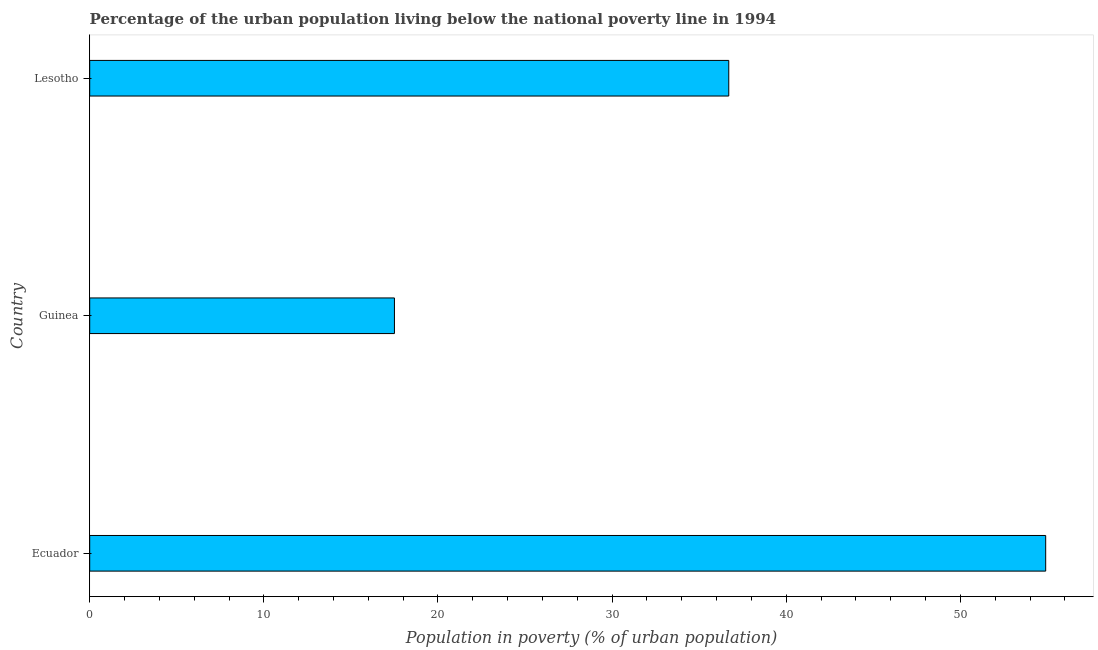Does the graph contain grids?
Your response must be concise. No. What is the title of the graph?
Give a very brief answer. Percentage of the urban population living below the national poverty line in 1994. What is the label or title of the X-axis?
Your answer should be compact. Population in poverty (% of urban population). What is the label or title of the Y-axis?
Give a very brief answer. Country. What is the percentage of urban population living below poverty line in Guinea?
Offer a terse response. 17.5. Across all countries, what is the maximum percentage of urban population living below poverty line?
Provide a succinct answer. 54.9. Across all countries, what is the minimum percentage of urban population living below poverty line?
Ensure brevity in your answer.  17.5. In which country was the percentage of urban population living below poverty line maximum?
Offer a very short reply. Ecuador. In which country was the percentage of urban population living below poverty line minimum?
Your response must be concise. Guinea. What is the sum of the percentage of urban population living below poverty line?
Provide a succinct answer. 109.1. What is the average percentage of urban population living below poverty line per country?
Give a very brief answer. 36.37. What is the median percentage of urban population living below poverty line?
Your response must be concise. 36.7. What is the ratio of the percentage of urban population living below poverty line in Guinea to that in Lesotho?
Provide a succinct answer. 0.48. Is the percentage of urban population living below poverty line in Ecuador less than that in Lesotho?
Offer a terse response. No. Is the difference between the percentage of urban population living below poverty line in Ecuador and Guinea greater than the difference between any two countries?
Provide a succinct answer. Yes. What is the difference between the highest and the second highest percentage of urban population living below poverty line?
Ensure brevity in your answer.  18.2. What is the difference between the highest and the lowest percentage of urban population living below poverty line?
Provide a succinct answer. 37.4. In how many countries, is the percentage of urban population living below poverty line greater than the average percentage of urban population living below poverty line taken over all countries?
Offer a terse response. 2. How many bars are there?
Make the answer very short. 3. What is the Population in poverty (% of urban population) in Ecuador?
Provide a short and direct response. 54.9. What is the Population in poverty (% of urban population) in Lesotho?
Offer a very short reply. 36.7. What is the difference between the Population in poverty (% of urban population) in Ecuador and Guinea?
Your response must be concise. 37.4. What is the difference between the Population in poverty (% of urban population) in Guinea and Lesotho?
Give a very brief answer. -19.2. What is the ratio of the Population in poverty (% of urban population) in Ecuador to that in Guinea?
Offer a terse response. 3.14. What is the ratio of the Population in poverty (% of urban population) in Ecuador to that in Lesotho?
Your response must be concise. 1.5. What is the ratio of the Population in poverty (% of urban population) in Guinea to that in Lesotho?
Your answer should be compact. 0.48. 